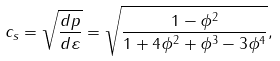<formula> <loc_0><loc_0><loc_500><loc_500>c _ { s } = \sqrt { \frac { d p } { d \varepsilon } } = \sqrt { \frac { 1 - \phi ^ { 2 } } { 1 + 4 \phi ^ { 2 } + \phi ^ { 3 } - 3 \phi ^ { 4 } } } ,</formula> 